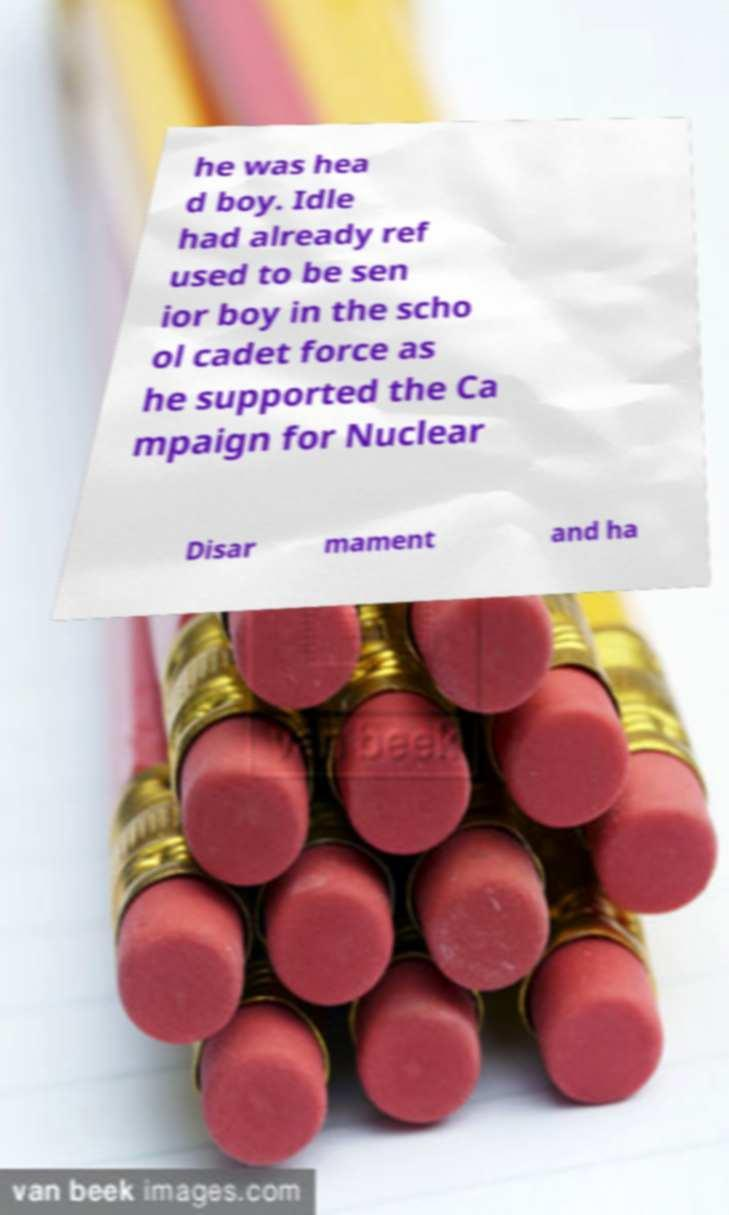Can you read and provide the text displayed in the image?This photo seems to have some interesting text. Can you extract and type it out for me? he was hea d boy. Idle had already ref used to be sen ior boy in the scho ol cadet force as he supported the Ca mpaign for Nuclear Disar mament and ha 